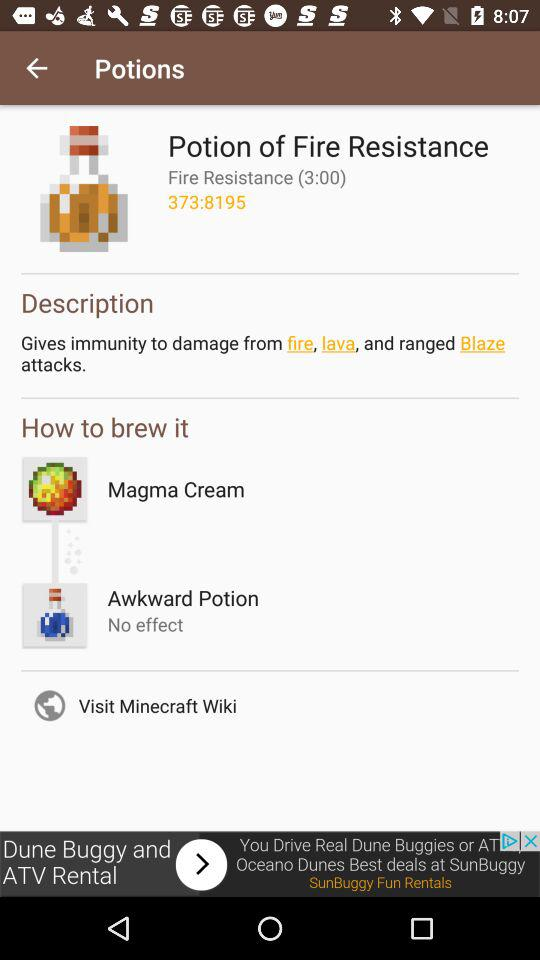What is the value of "Fire Resistance"? The value of "Fire Resistance" is 3:00. 